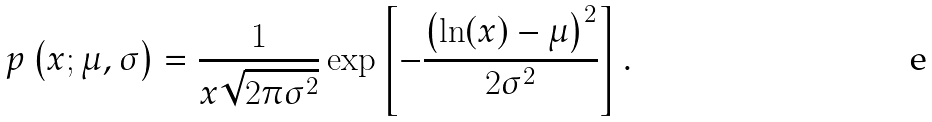Convert formula to latex. <formula><loc_0><loc_0><loc_500><loc_500>p \left ( x ; \mu , \sigma \right ) = \frac { 1 } { x \sqrt { 2 \pi \sigma ^ { 2 } } } \exp \left [ - \frac { \left ( \ln ( x ) - \mu \right ) ^ { 2 } } { 2 \sigma ^ { 2 } } \right ] .</formula> 